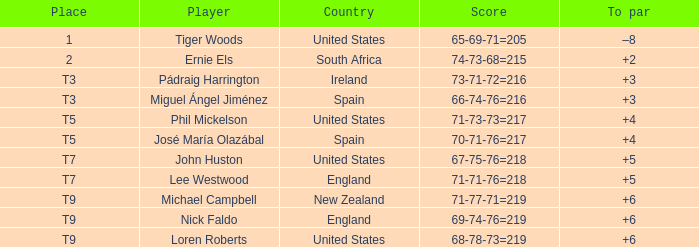What is Player, when Place is "1"? Tiger Woods. 